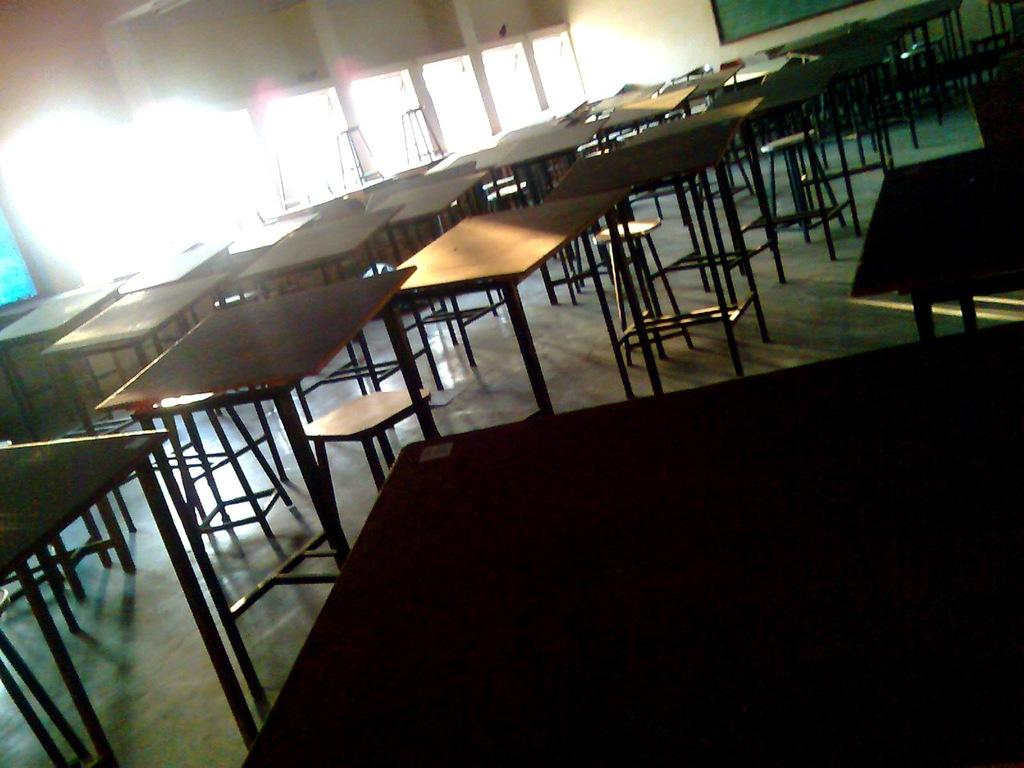What type of furniture is present in the image? There are tables and stools in the image. What can be seen through the windows in the image? The presence of windows suggests that there might be a view or outdoor scenery visible, but the specifics are not mentioned in the facts. What is the color of the board in the image? The board in the image is green. What time is displayed on the oven in the image? There is no oven present in the image, so it is not possible to determine the time displayed on it. 